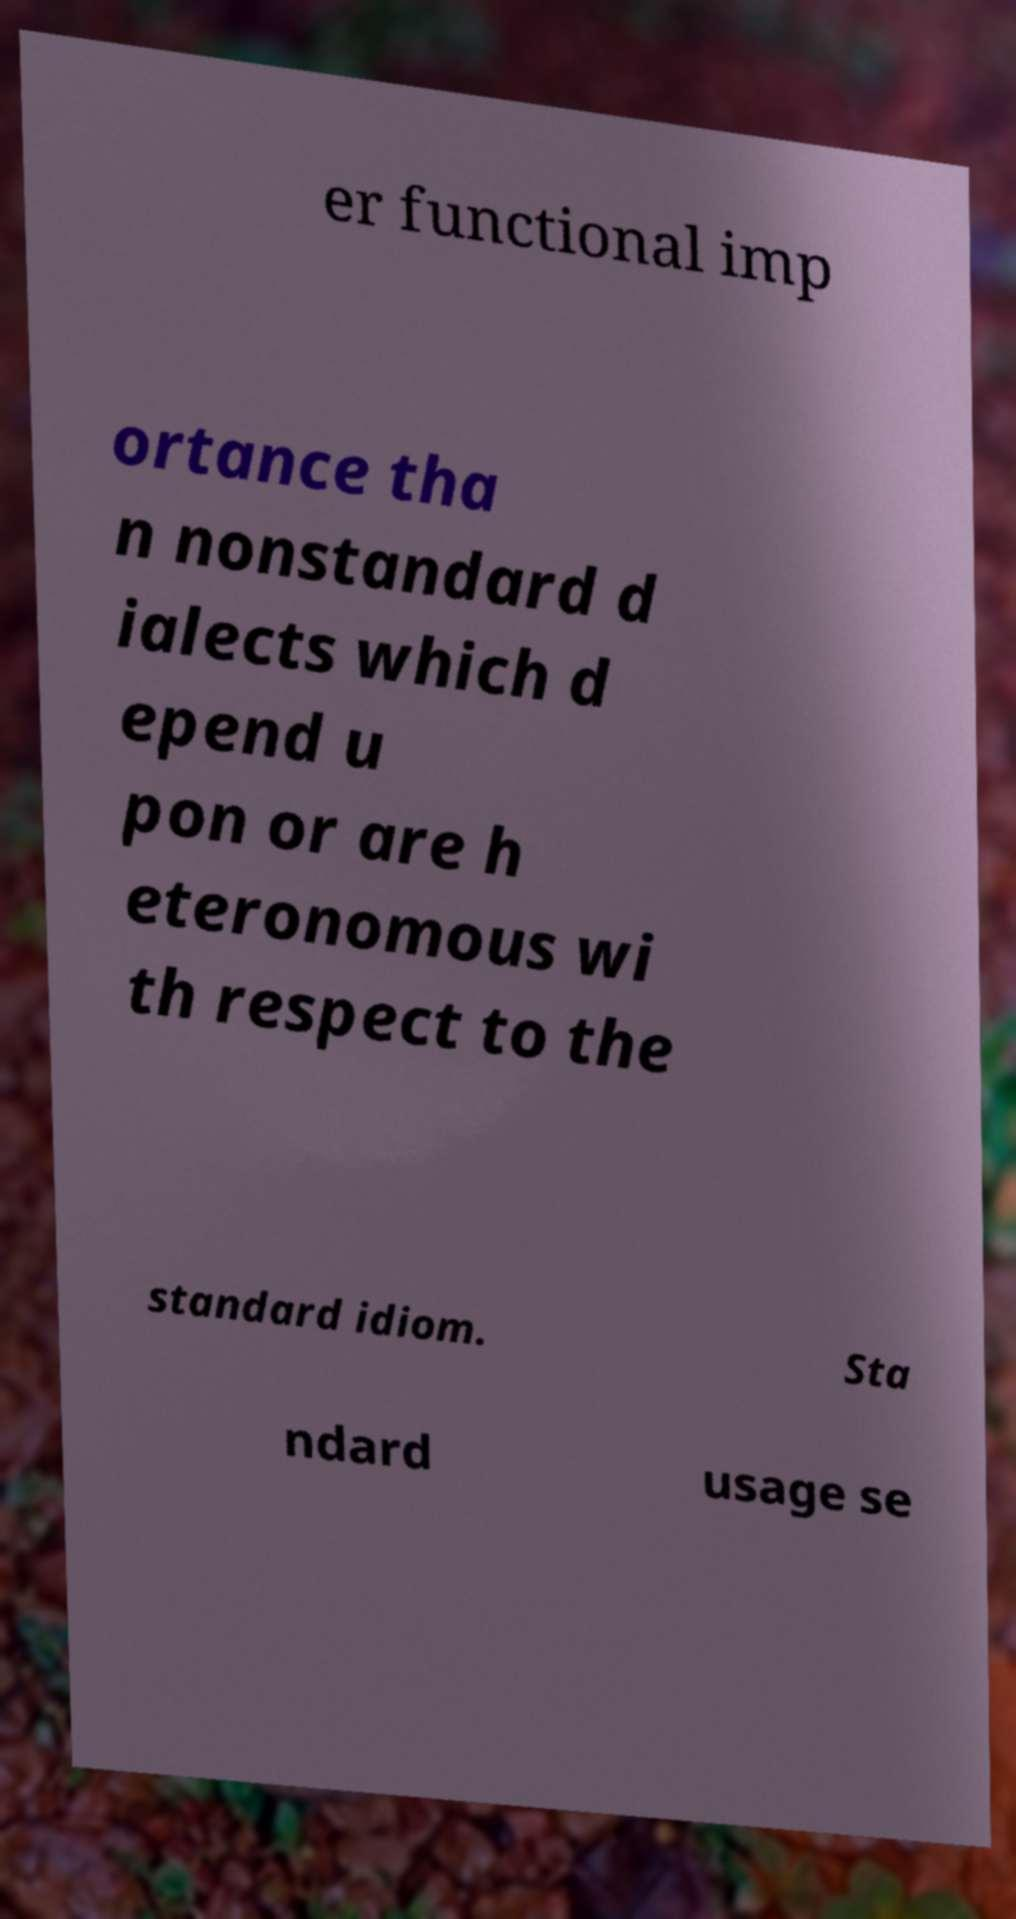Please identify and transcribe the text found in this image. er functional imp ortance tha n nonstandard d ialects which d epend u pon or are h eteronomous wi th respect to the standard idiom. Sta ndard usage se 